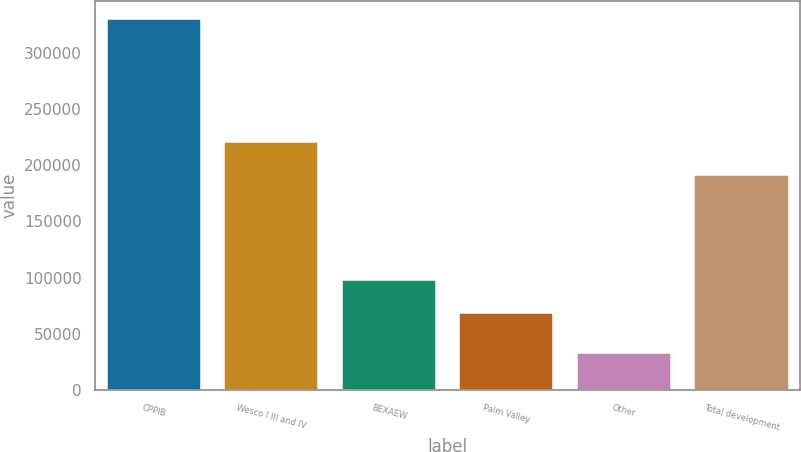Convert chart to OTSL. <chart><loc_0><loc_0><loc_500><loc_500><bar_chart><fcel>CPPIB<fcel>Wesco I III and IV<fcel>BEXAEW<fcel>Palm Valley<fcel>Other<fcel>Total development<nl><fcel>329723<fcel>220488<fcel>98204.6<fcel>68525<fcel>32927<fcel>190808<nl></chart> 